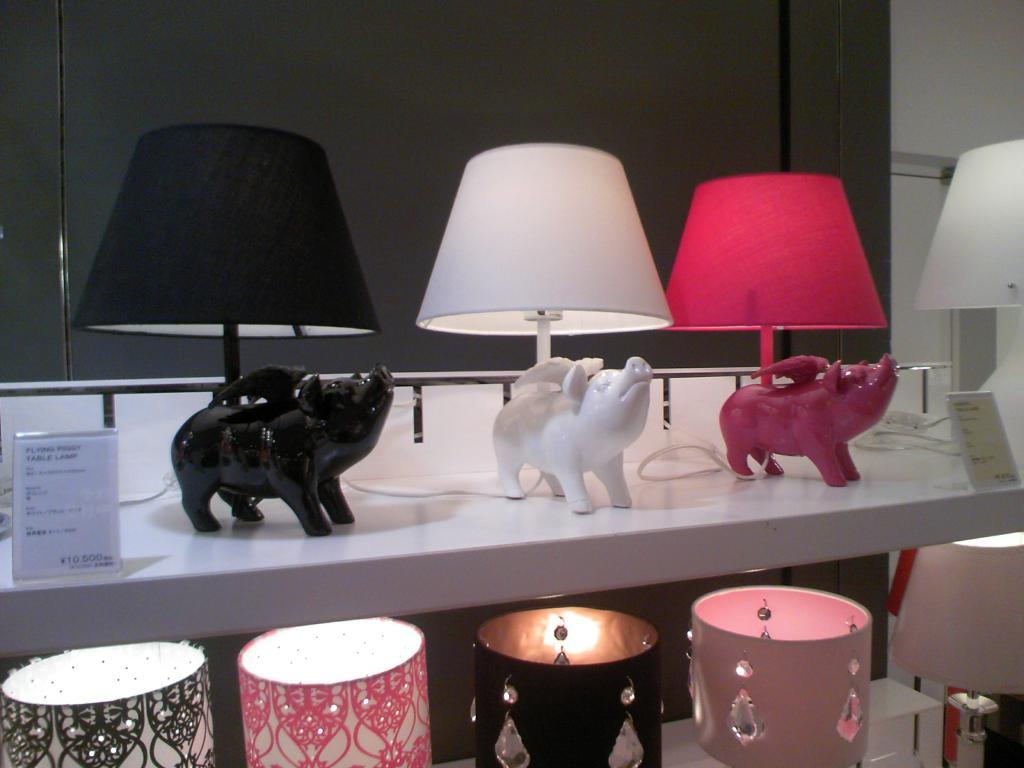What objects are hanging on the rack in the image? There are lamps, tags, and toys on the rack in the image. What might the tags be used for? The tags on the rack might be used for labeling or identifying the items. What type of items are on the rack? The items on the rack include lamps, tags, and toys. What type of invention is being demonstrated in the image? There is no invention being demonstrated in the image; it simply shows a rack with lamps, tags, and toys. 